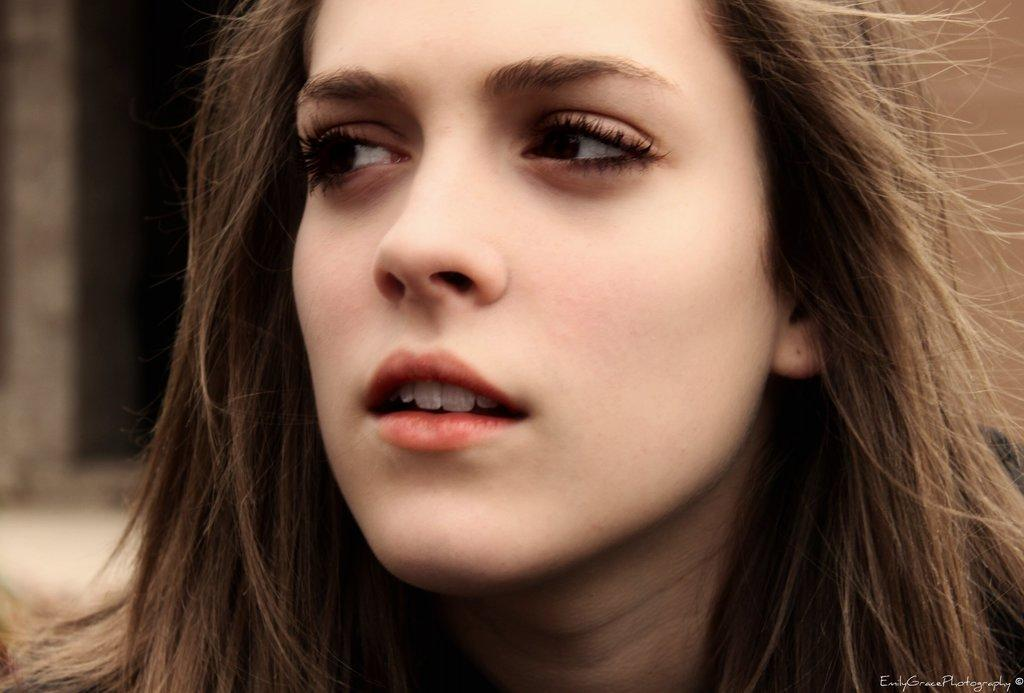What is the main subject in the foreground of the image? There is a woman's face in the foreground of the image. Can you describe the woman's hair in the image? The woman has loose hair. What can be observed about the background of the image? The background of the image is blurred. What does the woman's dad say about her hair in the image? There is no reference to the woman's dad or any dialogue in the image, so it is not possible to answer that question. 